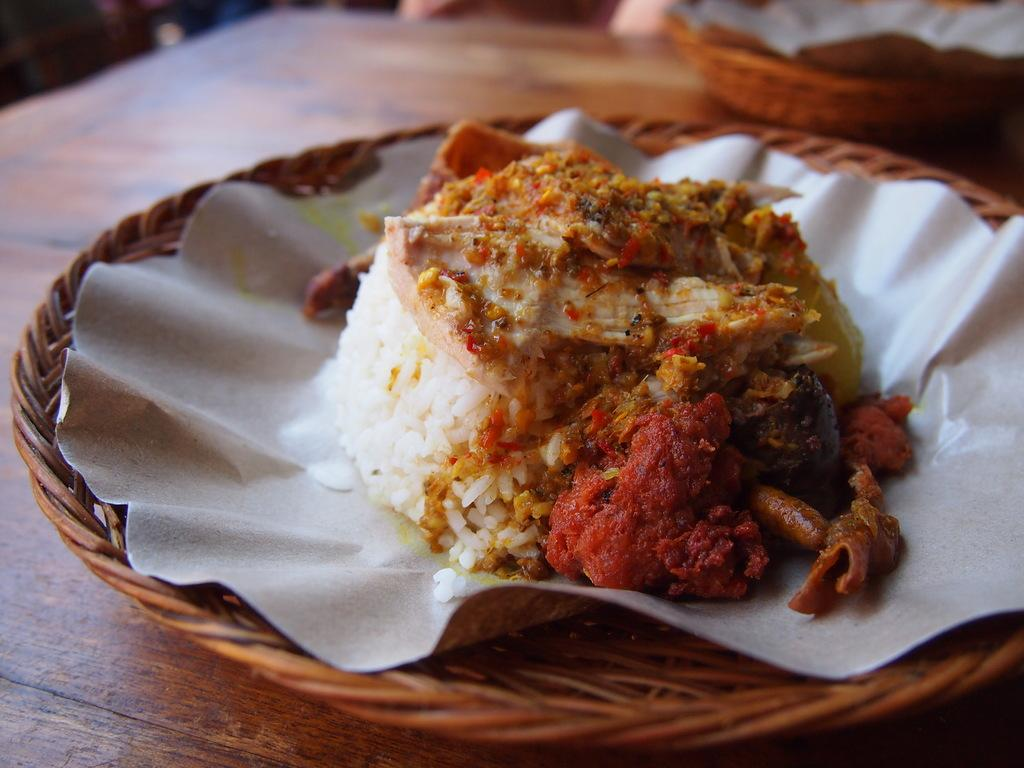What piece of furniture is present in the image? There is a table in the image. What is placed on the table? There is a wooden bowl on the table. What is inside the wooden bowl? There is a food item in the wooden bowl. What type of bedroom is shown in the image? There is no reference to a bedroom in the image. 